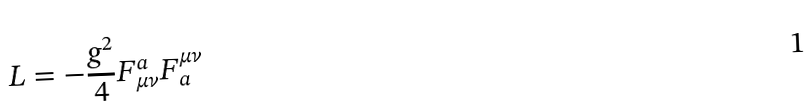<formula> <loc_0><loc_0><loc_500><loc_500>L = - \frac { g ^ { 2 } } { 4 } F _ { \mu \nu } ^ { a } F _ { a } ^ { \mu \nu }</formula> 